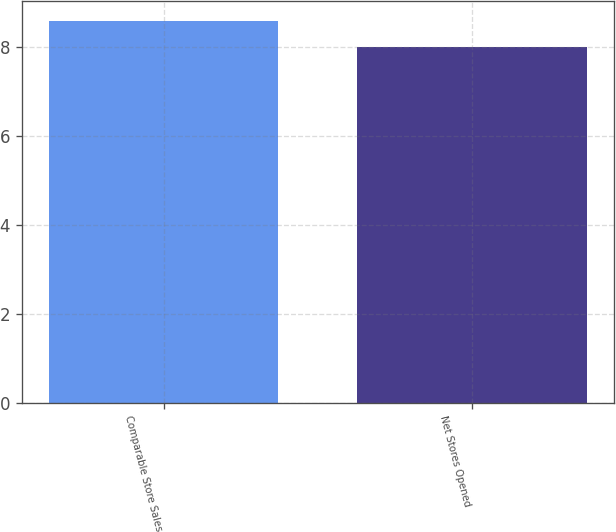<chart> <loc_0><loc_0><loc_500><loc_500><bar_chart><fcel>Comparable Store Sales<fcel>Net Stores Opened<nl><fcel>8.6<fcel>8<nl></chart> 